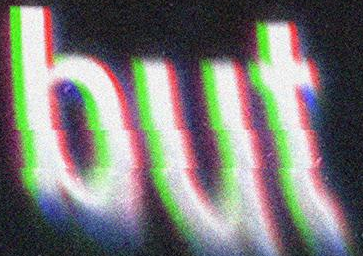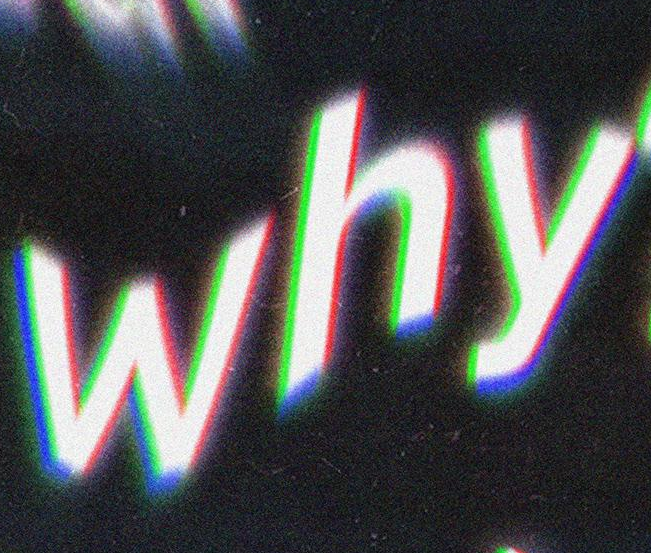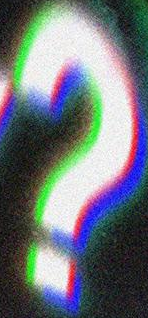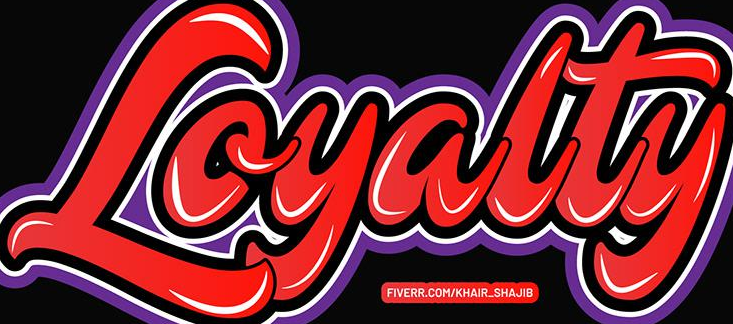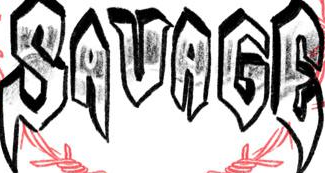Transcribe the words shown in these images in order, separated by a semicolon. but; why; ?; Loyalty; SAVAGE 